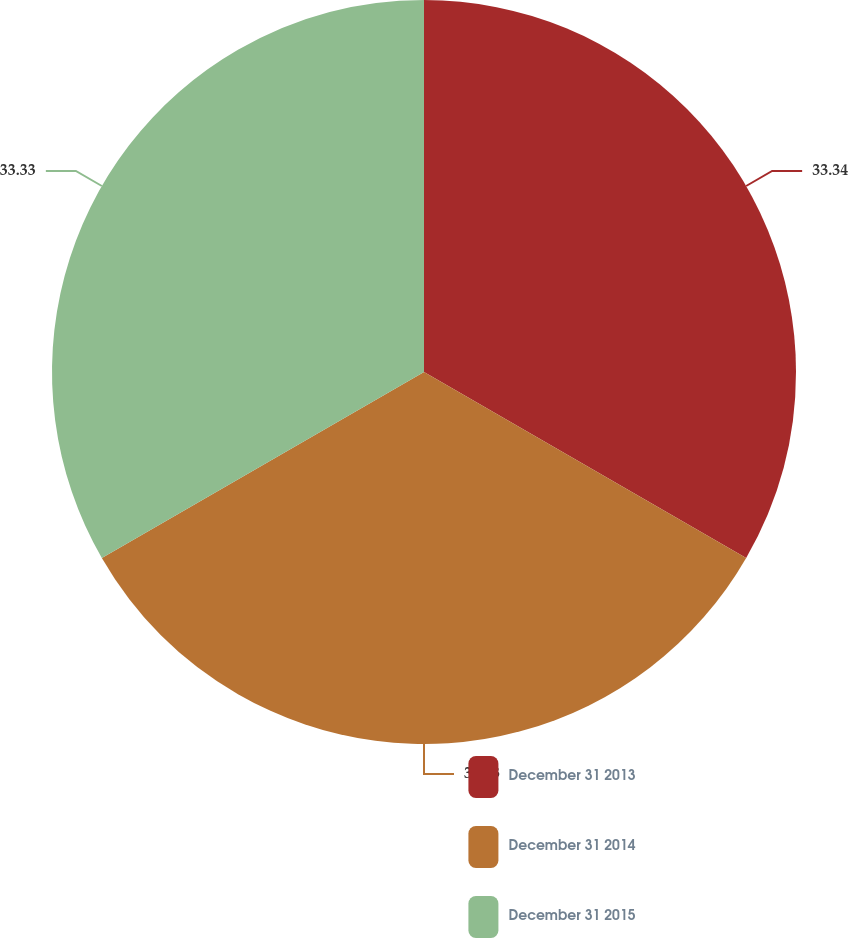<chart> <loc_0><loc_0><loc_500><loc_500><pie_chart><fcel>December 31 2013<fcel>December 31 2014<fcel>December 31 2015<nl><fcel>33.33%<fcel>33.33%<fcel>33.33%<nl></chart> 